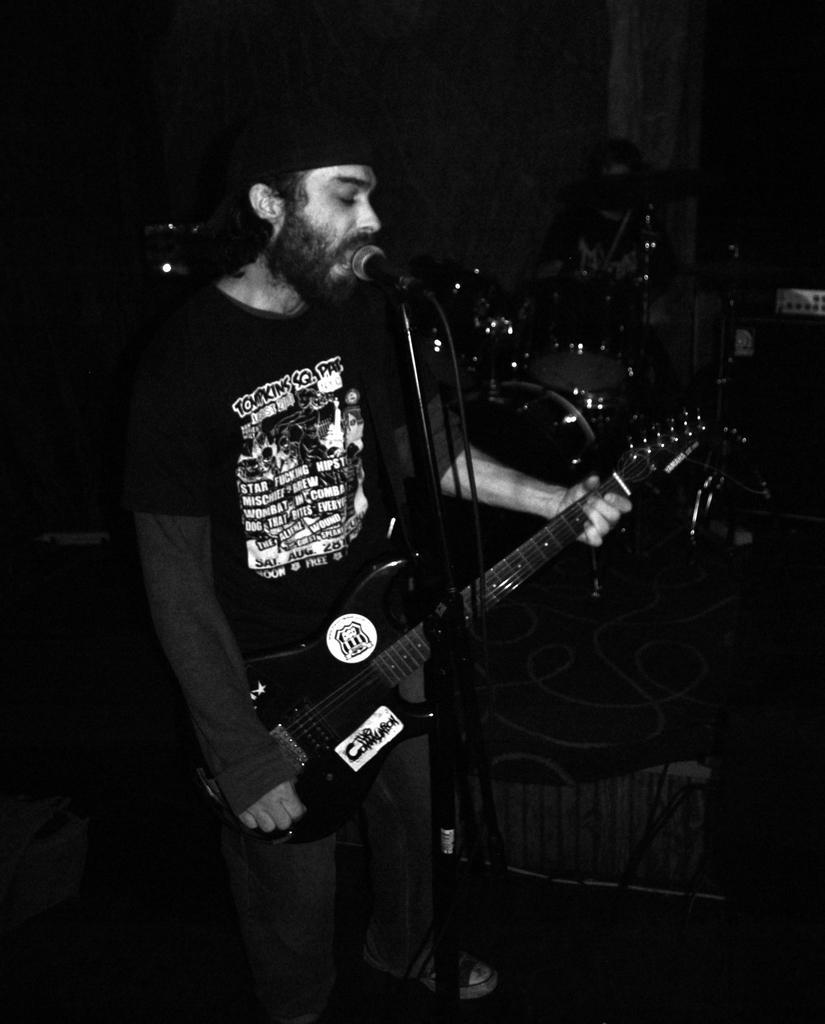Can you describe this image briefly? Her we can see a man standing and singing and holding a guitar in his hands, and in front here is the microphone, and at back here are the musical drums. 